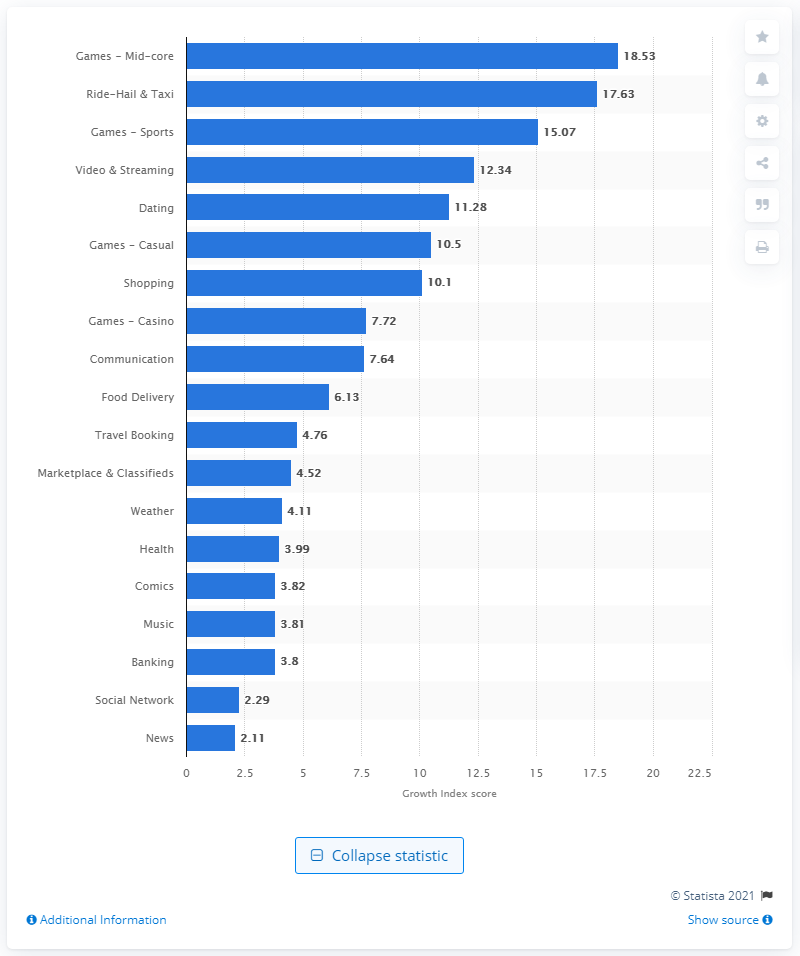Give some essential details in this illustration. In 2018, the Growth Index score for mid-core games was 18.53. 